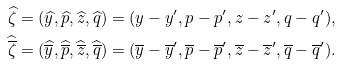Convert formula to latex. <formula><loc_0><loc_0><loc_500><loc_500>& \widehat { \zeta } = ( \widehat { y } , \widehat { p } , \widehat { z } , \widehat { q } ) = ( y - y ^ { \prime } , p - p ^ { \prime } , z - z ^ { \prime } , q - q ^ { \prime } ) , \\ & \widehat { \overline { \zeta } } = ( \widehat { \overline { y } } , \widehat { \overline { p } } , \widehat { \overline { z } } , \widehat { \overline { q } } ) = ( \overline { y } - \overline { y } ^ { \prime } , \overline { p } - \overline { p } ^ { \prime } , \overline { z } - \overline { z } ^ { \prime } , \overline { q } - \overline { q } ^ { \prime } ) .</formula> 